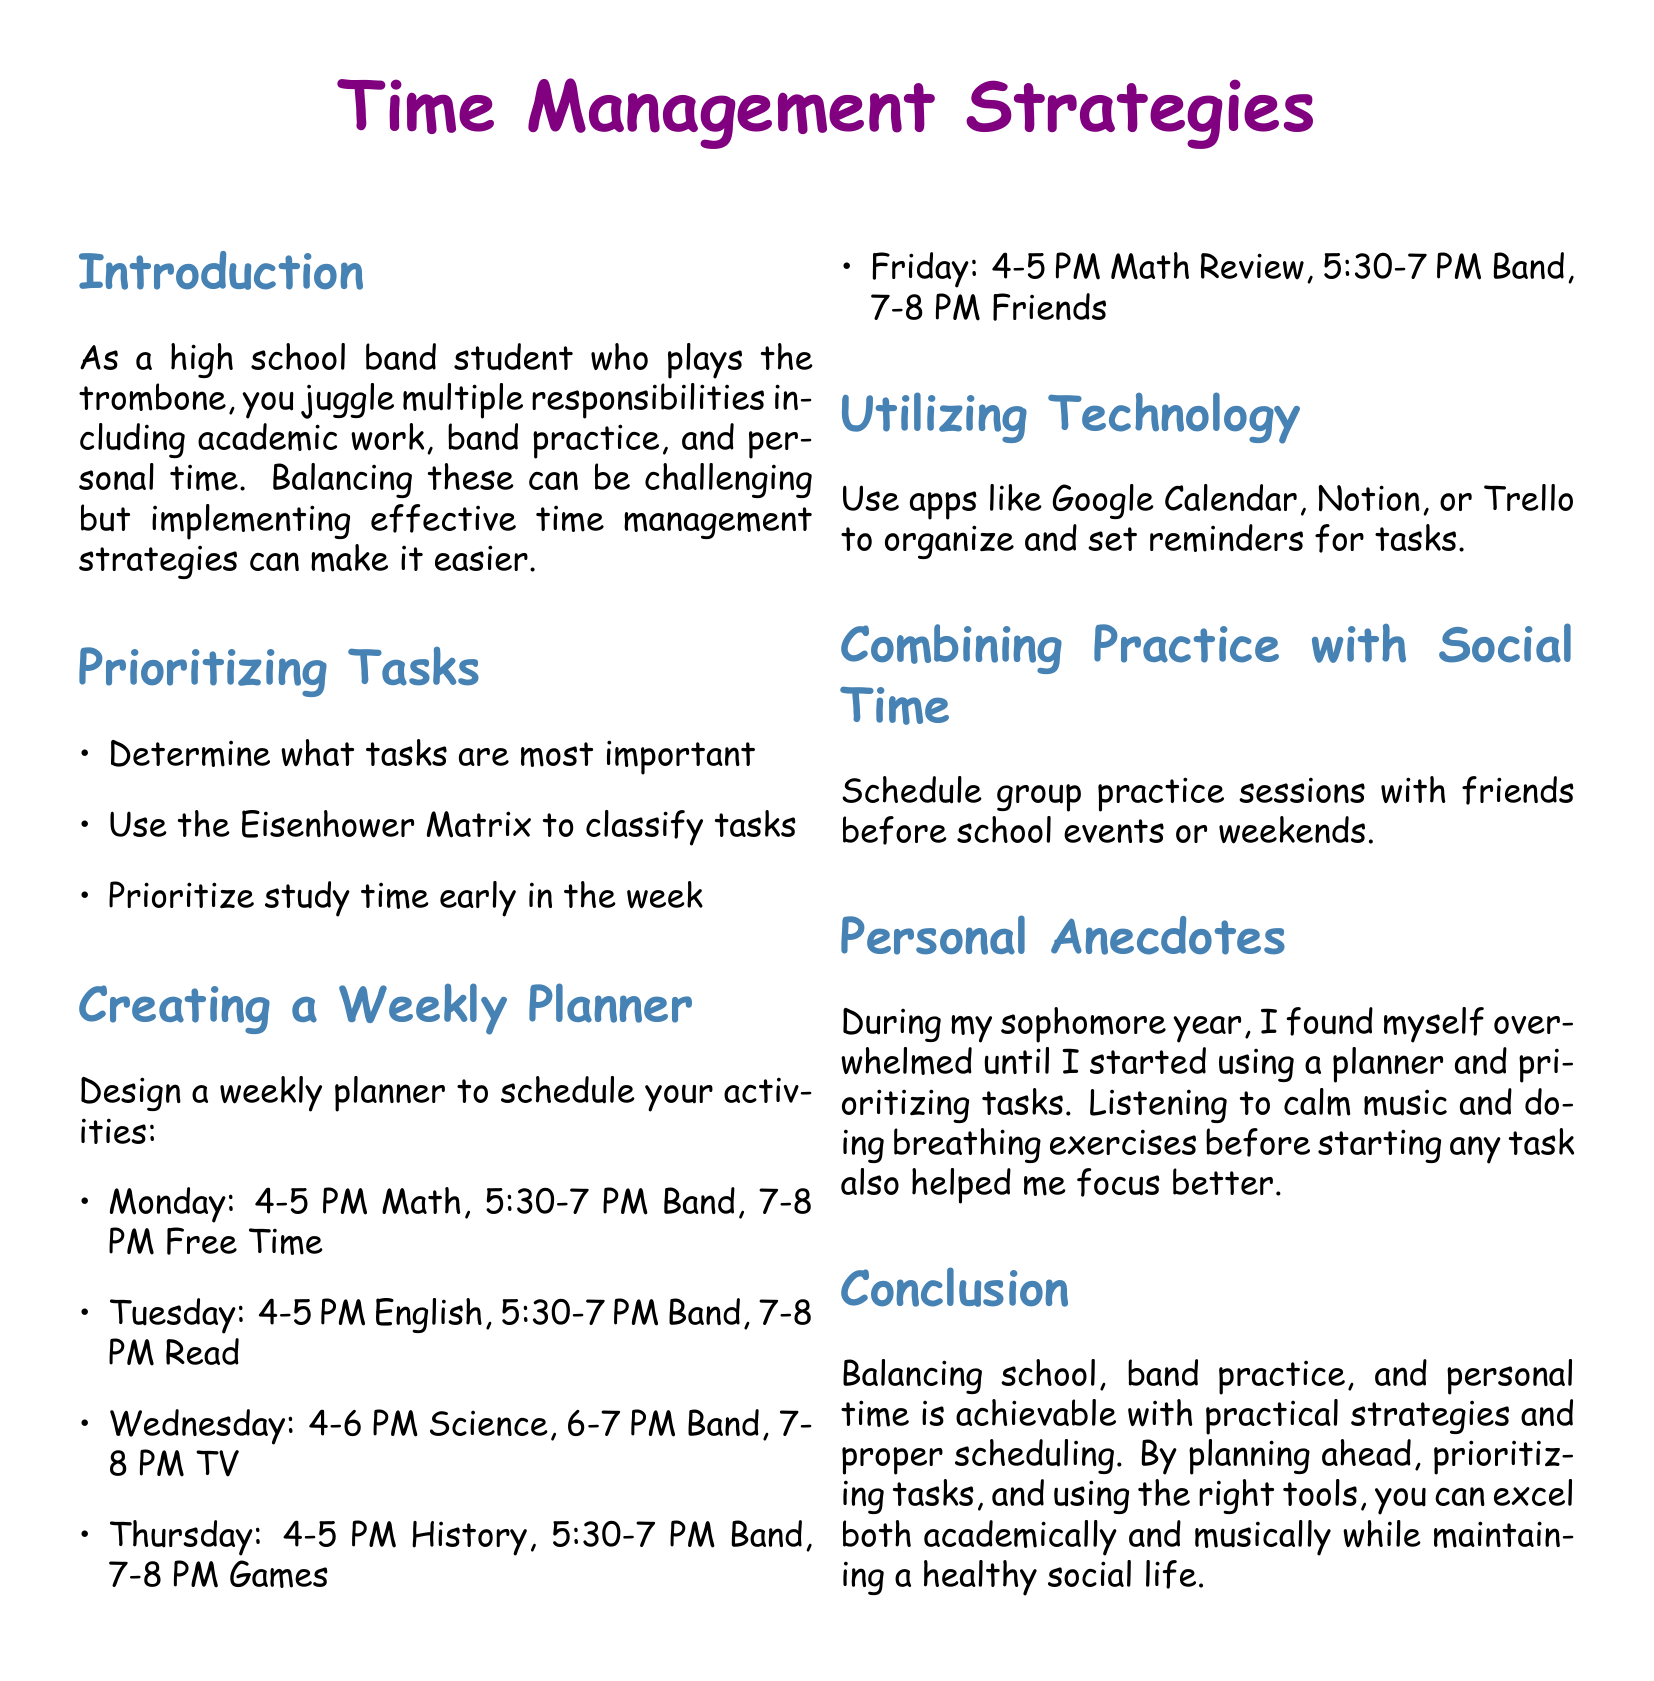What time is band practice on Monday? The document lists band practice from 5:30 to 7 PM on Monday.
Answer: 5:30-7 PM What app is suggested for organizing tasks? The document suggests apps like Google Calendar, Notion, or Trello for organizing tasks.
Answer: Google Calendar What is a key personal strategy mentioned for focusing better? The document mentions listening to calm music and doing breathing exercises as strategies for better focus.
Answer: Calm music What is the first task suggested for Tuesday? The document states the first task on Tuesday is English from 4-5 PM.
Answer: English What does the Eisenhower Matrix help with? The document states that the Eisenhower Matrix helps classify tasks to determine priority.
Answer: Classifying tasks How many hours are scheduled for Science on Wednesday? The document states that Science is scheduled for 2 hours on Wednesday from 4 to 6 PM.
Answer: 2 hours What is the main focus of the document? The document focuses on time management strategies for high school band students balancing academic work, band practice, and personal time.
Answer: Time management strategies What activity is scheduled after band practice on Friday? After band practice on Friday, the document lists "Friends" scheduled from 7 to 8 PM.
Answer: Friends 